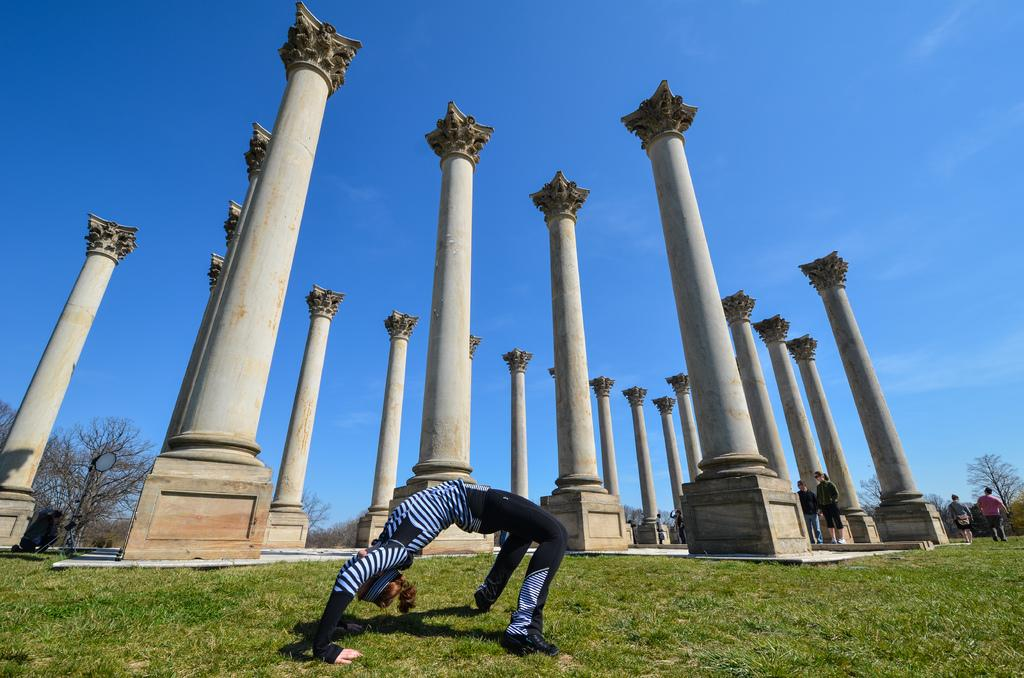What type of vegetation is present in the image? There is grass in the image. Who or what can be seen in the image? There are people in the image. What architectural feature is visible in the image? There are pillars in the image. What can be seen in the sky in the background of the image? There are clouds in the sky in the background of the image. What type of canvas is being used by the people in the image? There is no canvas present in the image; it features grass, people, pillars, and clouds. What angle are the pillars positioned at in the image? The angle of the pillars cannot be determined from the image, as they are depicted as standing upright. 